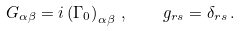Convert formula to latex. <formula><loc_0><loc_0><loc_500><loc_500>G _ { \alpha \beta } = i \left ( \Gamma _ { 0 } \right ) _ { \alpha \beta } \, , \quad g _ { r s } = \delta _ { r s } \, .</formula> 